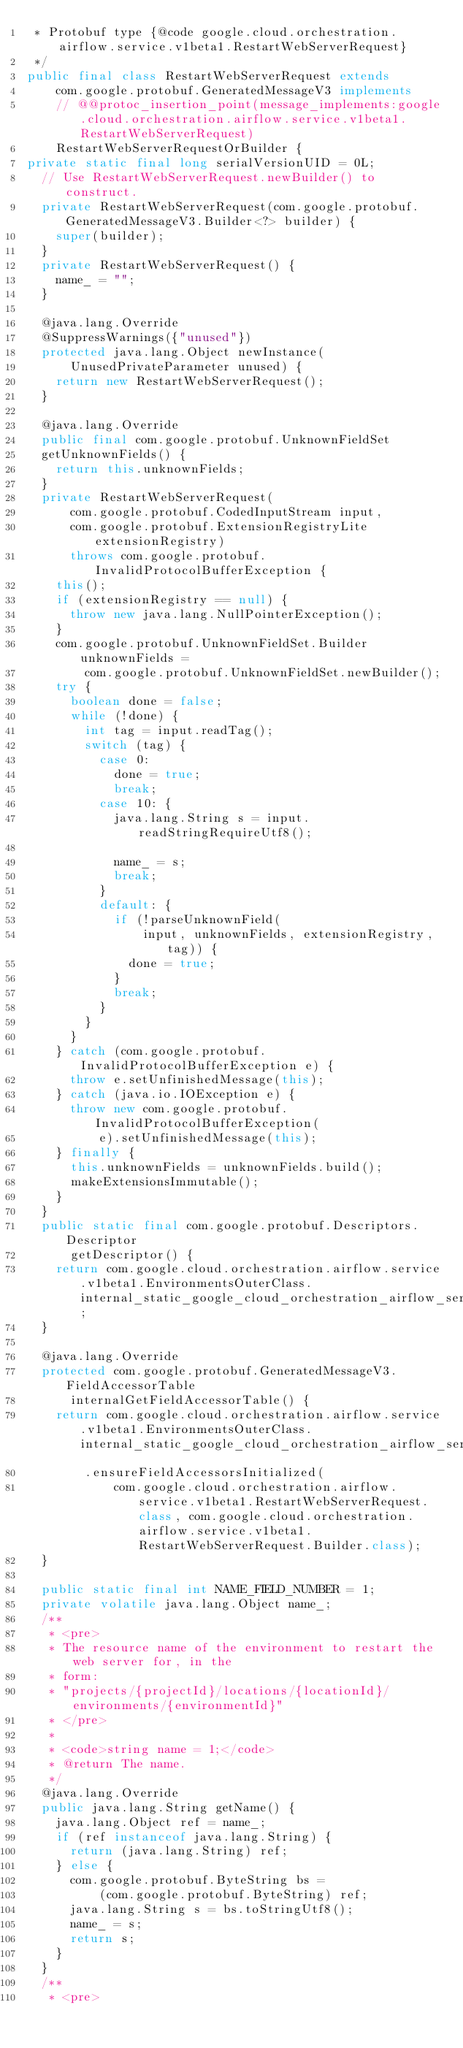Convert code to text. <code><loc_0><loc_0><loc_500><loc_500><_Java_> * Protobuf type {@code google.cloud.orchestration.airflow.service.v1beta1.RestartWebServerRequest}
 */
public final class RestartWebServerRequest extends
    com.google.protobuf.GeneratedMessageV3 implements
    // @@protoc_insertion_point(message_implements:google.cloud.orchestration.airflow.service.v1beta1.RestartWebServerRequest)
    RestartWebServerRequestOrBuilder {
private static final long serialVersionUID = 0L;
  // Use RestartWebServerRequest.newBuilder() to construct.
  private RestartWebServerRequest(com.google.protobuf.GeneratedMessageV3.Builder<?> builder) {
    super(builder);
  }
  private RestartWebServerRequest() {
    name_ = "";
  }

  @java.lang.Override
  @SuppressWarnings({"unused"})
  protected java.lang.Object newInstance(
      UnusedPrivateParameter unused) {
    return new RestartWebServerRequest();
  }

  @java.lang.Override
  public final com.google.protobuf.UnknownFieldSet
  getUnknownFields() {
    return this.unknownFields;
  }
  private RestartWebServerRequest(
      com.google.protobuf.CodedInputStream input,
      com.google.protobuf.ExtensionRegistryLite extensionRegistry)
      throws com.google.protobuf.InvalidProtocolBufferException {
    this();
    if (extensionRegistry == null) {
      throw new java.lang.NullPointerException();
    }
    com.google.protobuf.UnknownFieldSet.Builder unknownFields =
        com.google.protobuf.UnknownFieldSet.newBuilder();
    try {
      boolean done = false;
      while (!done) {
        int tag = input.readTag();
        switch (tag) {
          case 0:
            done = true;
            break;
          case 10: {
            java.lang.String s = input.readStringRequireUtf8();

            name_ = s;
            break;
          }
          default: {
            if (!parseUnknownField(
                input, unknownFields, extensionRegistry, tag)) {
              done = true;
            }
            break;
          }
        }
      }
    } catch (com.google.protobuf.InvalidProtocolBufferException e) {
      throw e.setUnfinishedMessage(this);
    } catch (java.io.IOException e) {
      throw new com.google.protobuf.InvalidProtocolBufferException(
          e).setUnfinishedMessage(this);
    } finally {
      this.unknownFields = unknownFields.build();
      makeExtensionsImmutable();
    }
  }
  public static final com.google.protobuf.Descriptors.Descriptor
      getDescriptor() {
    return com.google.cloud.orchestration.airflow.service.v1beta1.EnvironmentsOuterClass.internal_static_google_cloud_orchestration_airflow_service_v1beta1_RestartWebServerRequest_descriptor;
  }

  @java.lang.Override
  protected com.google.protobuf.GeneratedMessageV3.FieldAccessorTable
      internalGetFieldAccessorTable() {
    return com.google.cloud.orchestration.airflow.service.v1beta1.EnvironmentsOuterClass.internal_static_google_cloud_orchestration_airflow_service_v1beta1_RestartWebServerRequest_fieldAccessorTable
        .ensureFieldAccessorsInitialized(
            com.google.cloud.orchestration.airflow.service.v1beta1.RestartWebServerRequest.class, com.google.cloud.orchestration.airflow.service.v1beta1.RestartWebServerRequest.Builder.class);
  }

  public static final int NAME_FIELD_NUMBER = 1;
  private volatile java.lang.Object name_;
  /**
   * <pre>
   * The resource name of the environment to restart the web server for, in the
   * form:
   * "projects/{projectId}/locations/{locationId}/environments/{environmentId}"
   * </pre>
   *
   * <code>string name = 1;</code>
   * @return The name.
   */
  @java.lang.Override
  public java.lang.String getName() {
    java.lang.Object ref = name_;
    if (ref instanceof java.lang.String) {
      return (java.lang.String) ref;
    } else {
      com.google.protobuf.ByteString bs = 
          (com.google.protobuf.ByteString) ref;
      java.lang.String s = bs.toStringUtf8();
      name_ = s;
      return s;
    }
  }
  /**
   * <pre></code> 